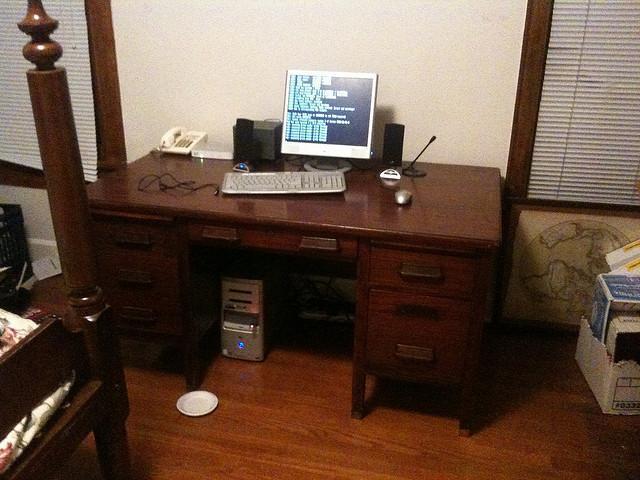How many phones are in this photo?
Give a very brief answer. 1. How many people are surfing?
Give a very brief answer. 0. 